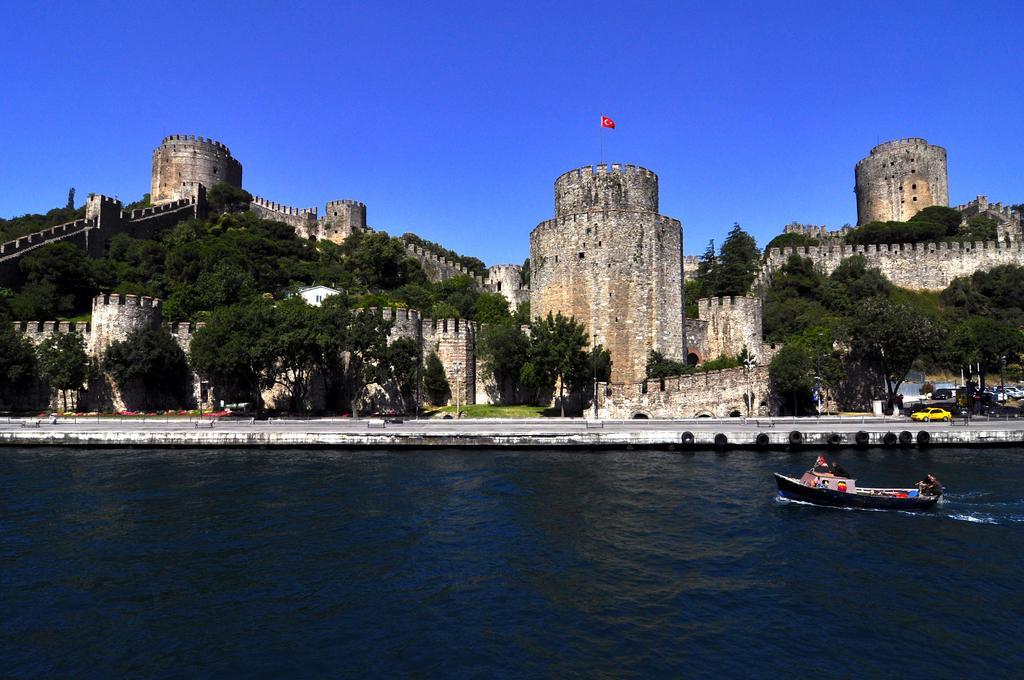Can you describe this image briefly? In this picture I can see a fort and a flag and I can see trees and few cars. I can see a boat on the water and couple of persons are in the boat and a blue sky 